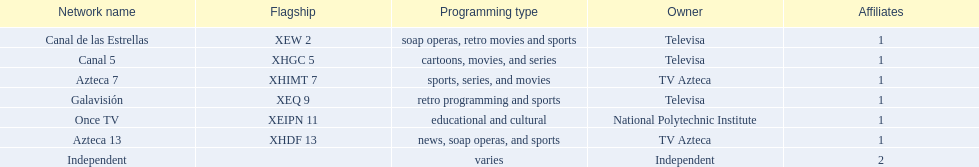Among all networks, what is the cumulative number of affiliates? 8. 